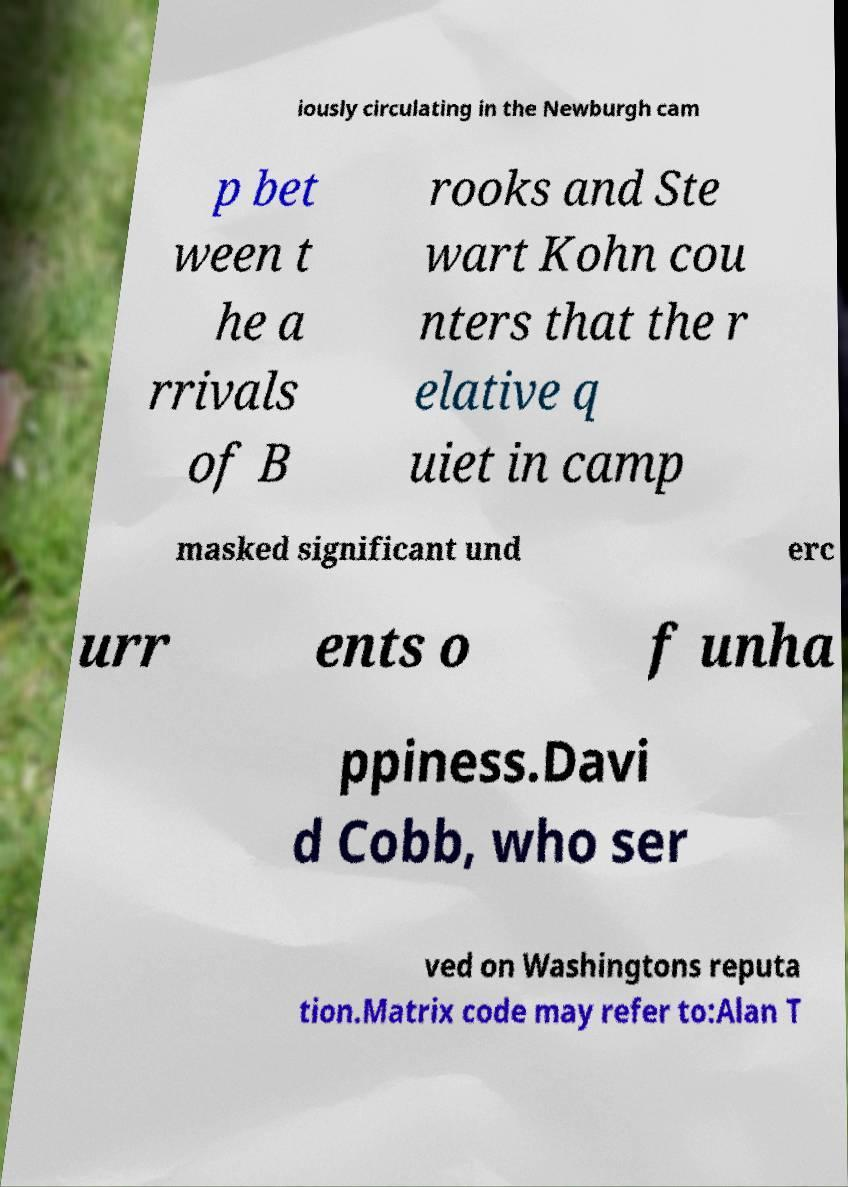Please read and relay the text visible in this image. What does it say? iously circulating in the Newburgh cam p bet ween t he a rrivals of B rooks and Ste wart Kohn cou nters that the r elative q uiet in camp masked significant und erc urr ents o f unha ppiness.Davi d Cobb, who ser ved on Washingtons reputa tion.Matrix code may refer to:Alan T 